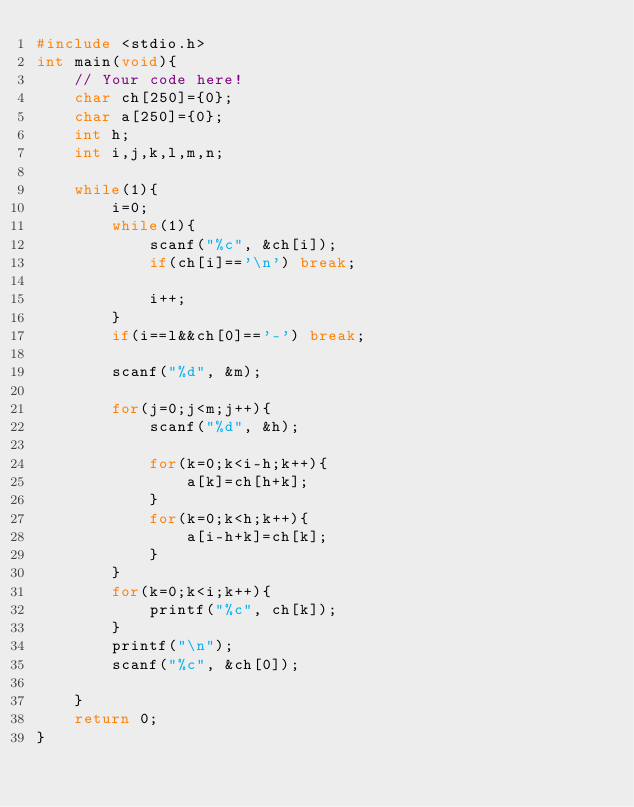Convert code to text. <code><loc_0><loc_0><loc_500><loc_500><_C_>#include <stdio.h>
int main(void){
    // Your code here!
    char ch[250]={0};
    char a[250]={0};
    int h;
    int i,j,k,l,m,n;
    
    while(1){
        i=0;
        while(1){
            scanf("%c", &ch[i]);
            if(ch[i]=='\n') break;
            
            i++;
        }
        if(i==l&&ch[0]=='-') break;
        
        scanf("%d", &m);
        
        for(j=0;j<m;j++){
            scanf("%d", &h);
            
            for(k=0;k<i-h;k++){
                a[k]=ch[h+k];
            }
            for(k=0;k<h;k++){
                a[i-h+k]=ch[k];
            }
        }
        for(k=0;k<i;k++){
            printf("%c", ch[k]);
        }
        printf("\n");
        scanf("%c", &ch[0]);

    }
    return 0;
}

</code> 